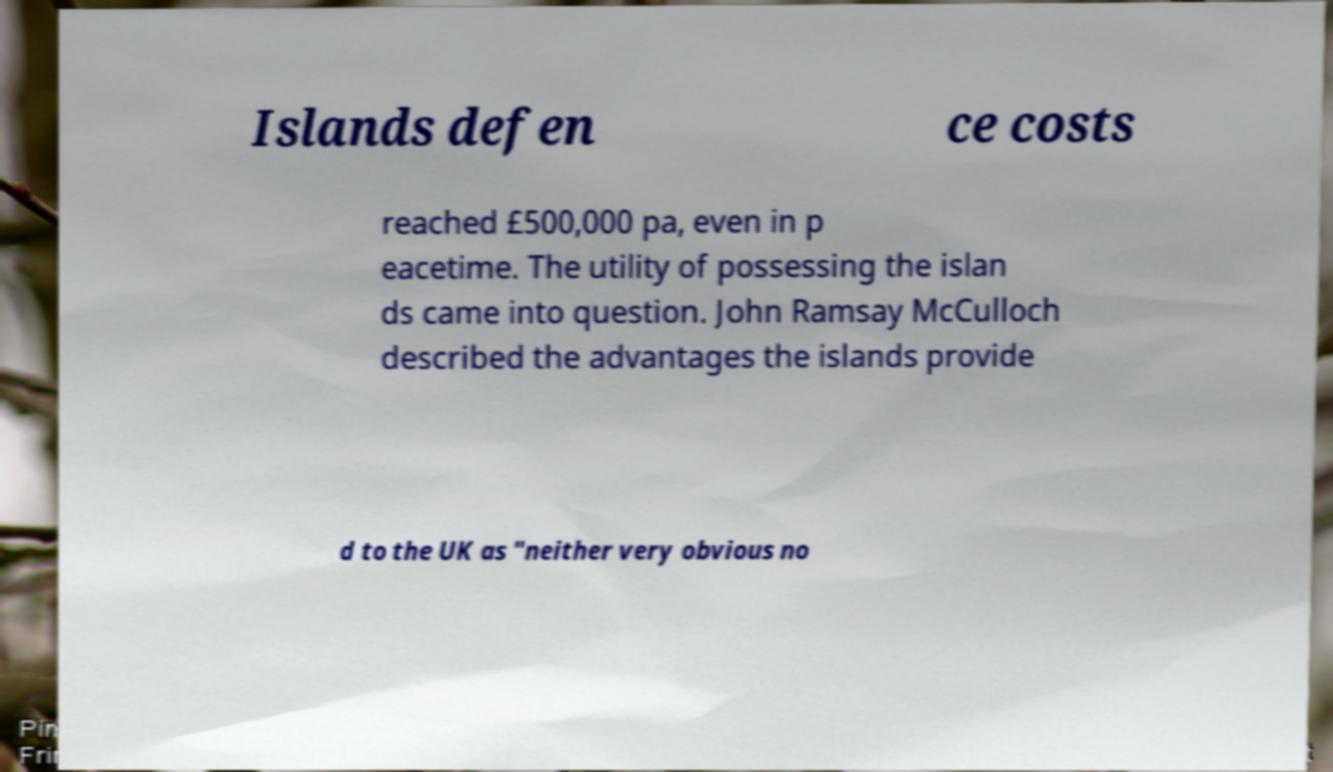There's text embedded in this image that I need extracted. Can you transcribe it verbatim? Islands defen ce costs reached £500,000 pa, even in p eacetime. The utility of possessing the islan ds came into question. John Ramsay McCulloch described the advantages the islands provide d to the UK as "neither very obvious no 